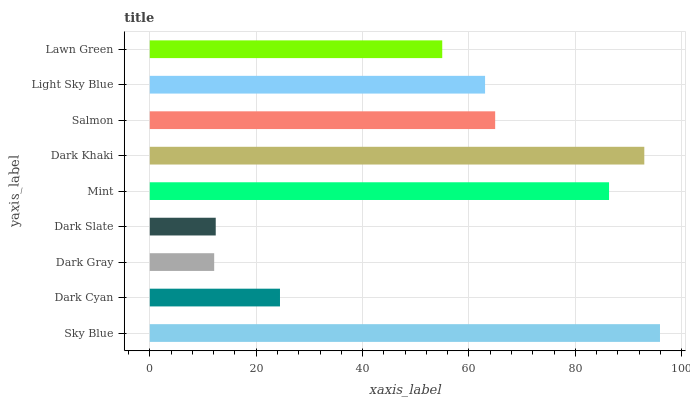Is Dark Gray the minimum?
Answer yes or no. Yes. Is Sky Blue the maximum?
Answer yes or no. Yes. Is Dark Cyan the minimum?
Answer yes or no. No. Is Dark Cyan the maximum?
Answer yes or no. No. Is Sky Blue greater than Dark Cyan?
Answer yes or no. Yes. Is Dark Cyan less than Sky Blue?
Answer yes or no. Yes. Is Dark Cyan greater than Sky Blue?
Answer yes or no. No. Is Sky Blue less than Dark Cyan?
Answer yes or no. No. Is Light Sky Blue the high median?
Answer yes or no. Yes. Is Light Sky Blue the low median?
Answer yes or no. Yes. Is Salmon the high median?
Answer yes or no. No. Is Dark Slate the low median?
Answer yes or no. No. 